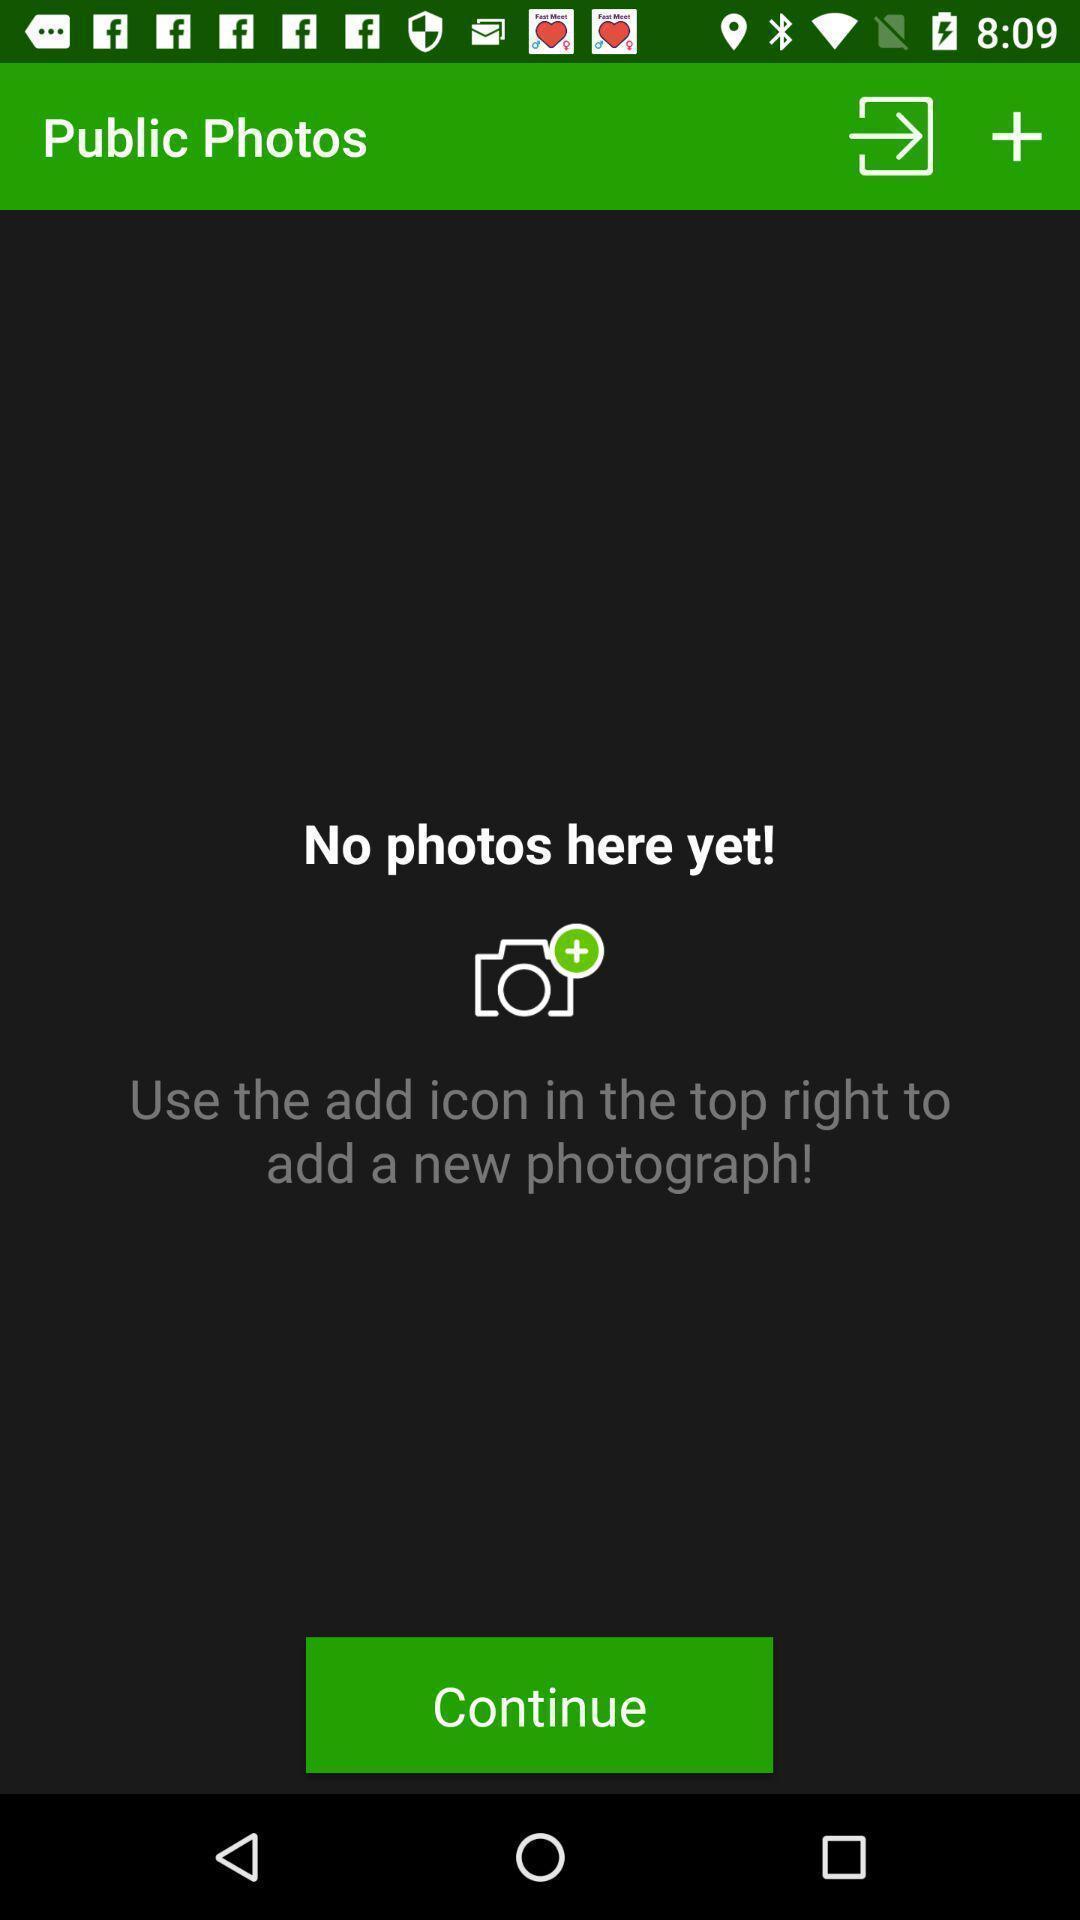Describe this image in words. Screen displaying the photos page with no content. 